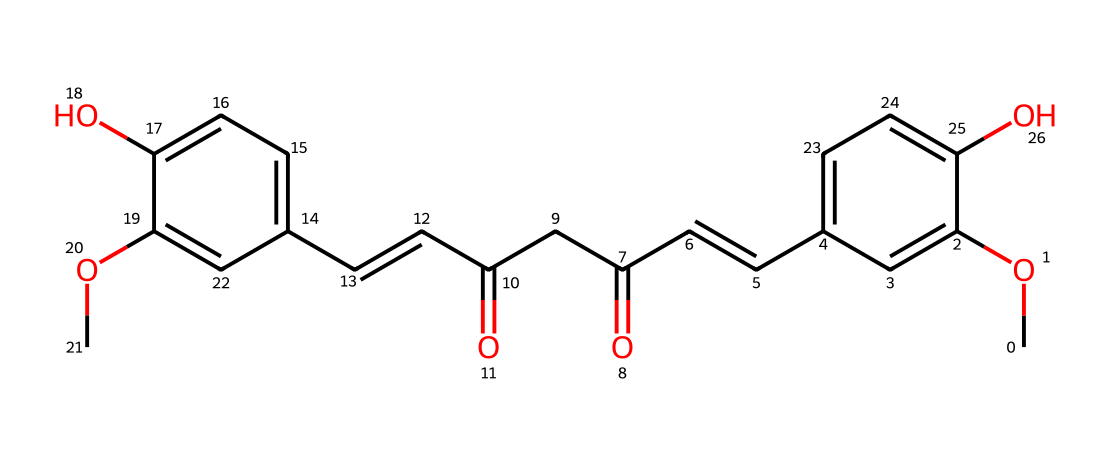How many carbon atoms are in curcumin? By examining the SMILES representation, we can count the number of carbon (C) symbols. Each distinct carbon atom in the structure contributes to the total count. In total, there are 21 carbon atoms present.
Answer: 21 What is the total number of hydroxyl (–OH) groups in curcumin? Looking at the SMILES, we can identify the hydroxyl groups typically represented by “O” directly bonded to carbon. In this case, there are two such groups in curcumin.
Answer: 2 How many double bonds are present in curcumin? The presence of double bonds can be detected by the “=” in the SMILES notation. By scanning the entire SMILES, we find there are three double bonds in the molecule.
Answer: 3 What functional group is indicated by the "CC(=O)" in curcumin? The notation "CC(=O)" signifies a carbon chain with a carbonyl group (C=O) attached to it. This functional group suggests the presence of a ketone or aldehyde. As it appears here, it corresponds to a diketone structure.
Answer: diketone Which ring structure is apparent in curcumin? The presence of cyclical structure can be noted by the repeating "c" and the numbers indicating connections. In curcumin, this indicates that there are two aromatic rings.
Answer: two aromatic rings What type of chemical compound is curcumin classified as? Analyzing its structure and functional groups, curcumin fits the characteristics of an aromatic compound due to its cyclic nature and presence of conjugated double bonds between the carbon atoms.
Answer: aromatic compound 